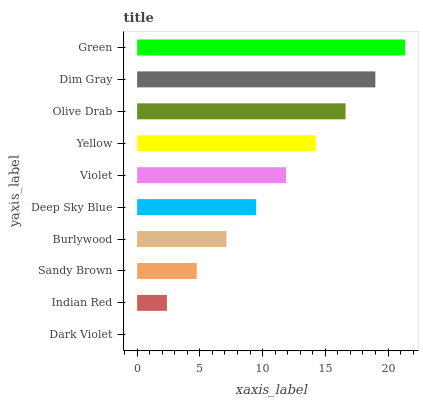Is Dark Violet the minimum?
Answer yes or no. Yes. Is Green the maximum?
Answer yes or no. Yes. Is Indian Red the minimum?
Answer yes or no. No. Is Indian Red the maximum?
Answer yes or no. No. Is Indian Red greater than Dark Violet?
Answer yes or no. Yes. Is Dark Violet less than Indian Red?
Answer yes or no. Yes. Is Dark Violet greater than Indian Red?
Answer yes or no. No. Is Indian Red less than Dark Violet?
Answer yes or no. No. Is Violet the high median?
Answer yes or no. Yes. Is Deep Sky Blue the low median?
Answer yes or no. Yes. Is Burlywood the high median?
Answer yes or no. No. Is Olive Drab the low median?
Answer yes or no. No. 